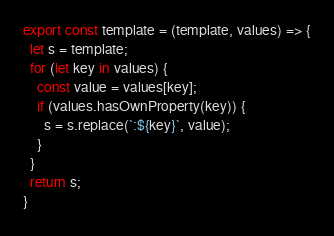<code> <loc_0><loc_0><loc_500><loc_500><_JavaScript_>export const template = (template, values) => {
  let s = template;
  for (let key in values) {
    const value = values[key];
    if (values.hasOwnProperty(key)) {
      s = s.replace(`:${key}`, value);
    }
  }
  return s;
}
</code> 